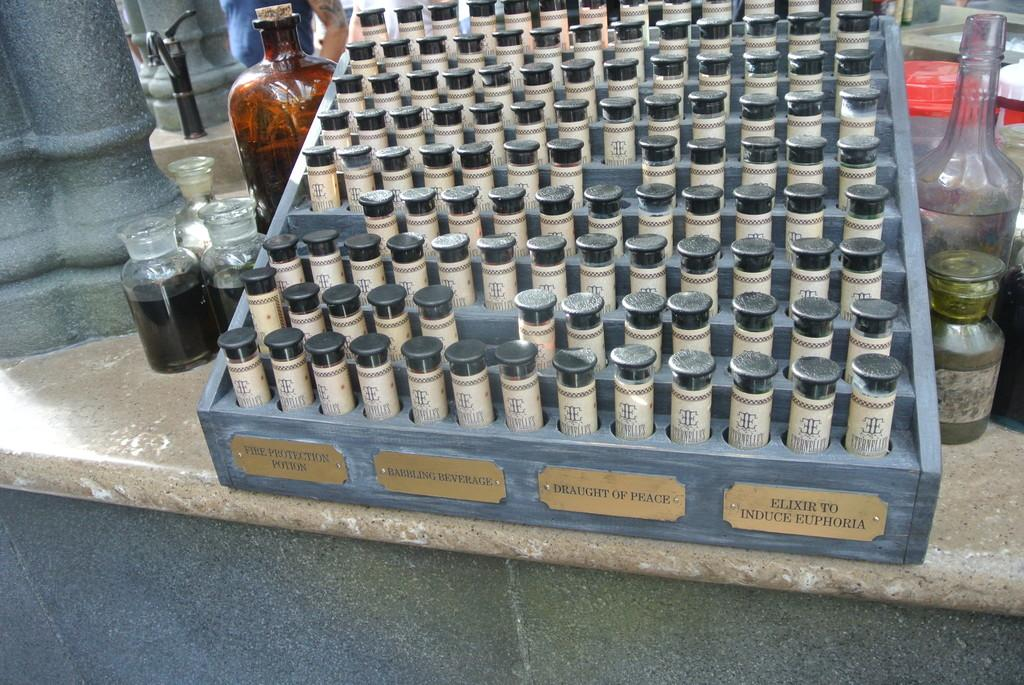<image>
Give a short and clear explanation of the subsequent image. a lot of small bottle with a label fire protection potion on the front of the case. 